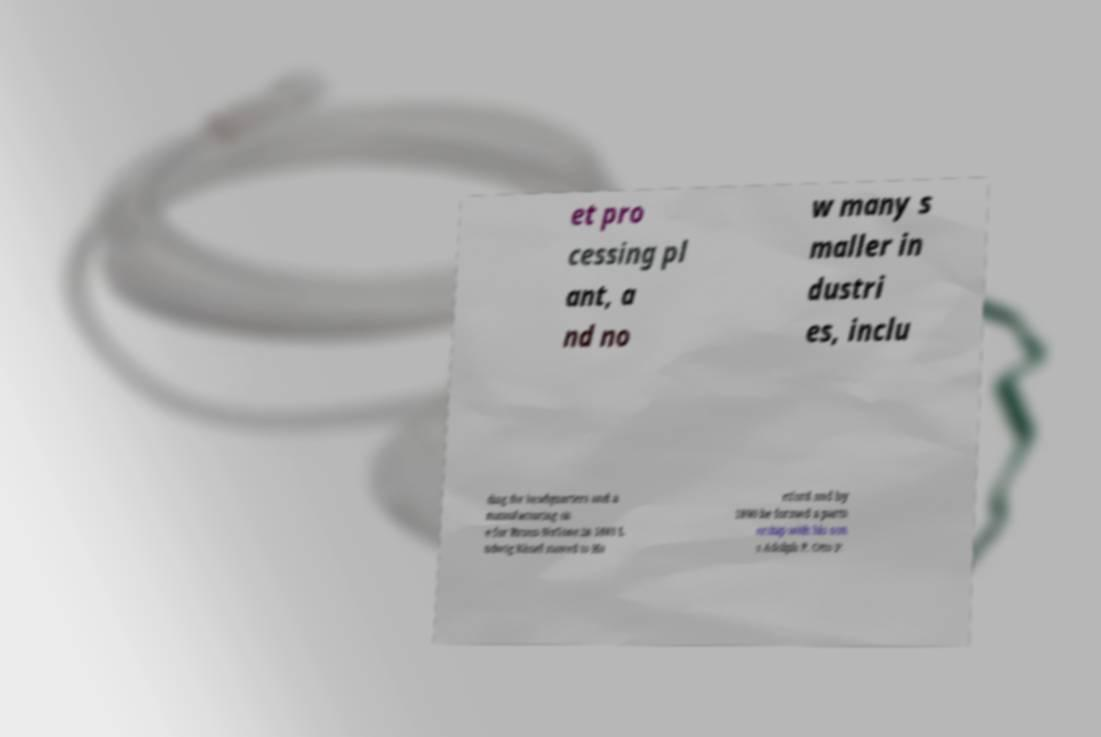Please identify and transcribe the text found in this image. et pro cessing pl ant, a nd no w many s maller in dustri es, inclu ding the headquarters and a manufacturing sit e for Broan-NuTone.In 1883 L udwig Kissel moved to Ha rtford and by 1890 he formed a partn ership with his son s Adolph P. Otto P. 